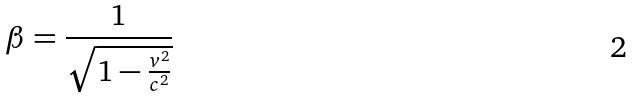Convert formula to latex. <formula><loc_0><loc_0><loc_500><loc_500>\beta = \frac { 1 } { \sqrt { 1 - \frac { v ^ { 2 } } { c ^ { 2 } } } }</formula> 